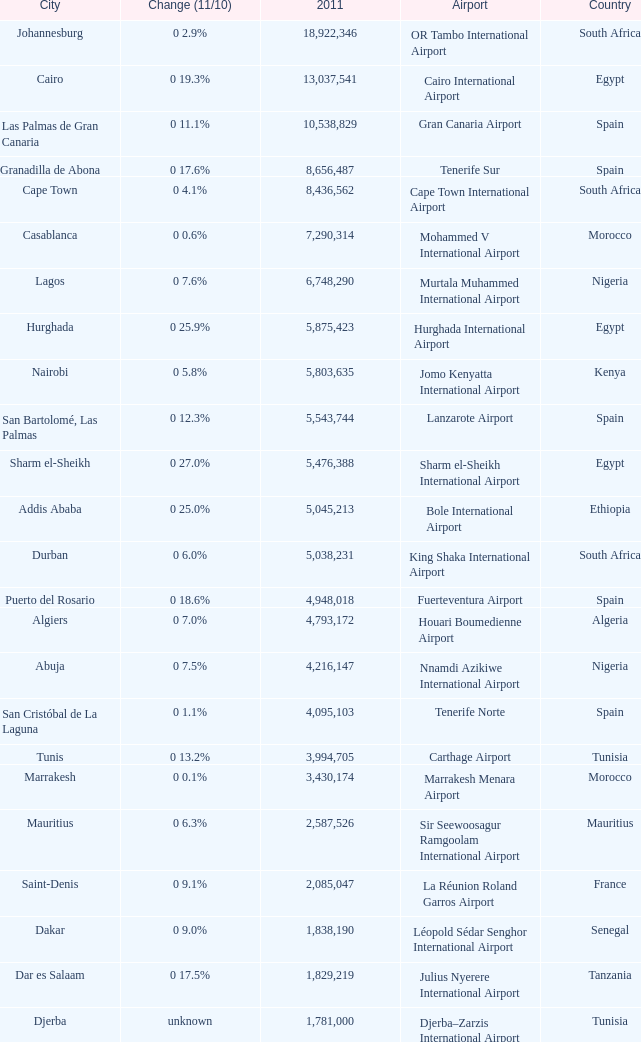Which 2011 has an Airport of bole international airport? 5045213.0. 